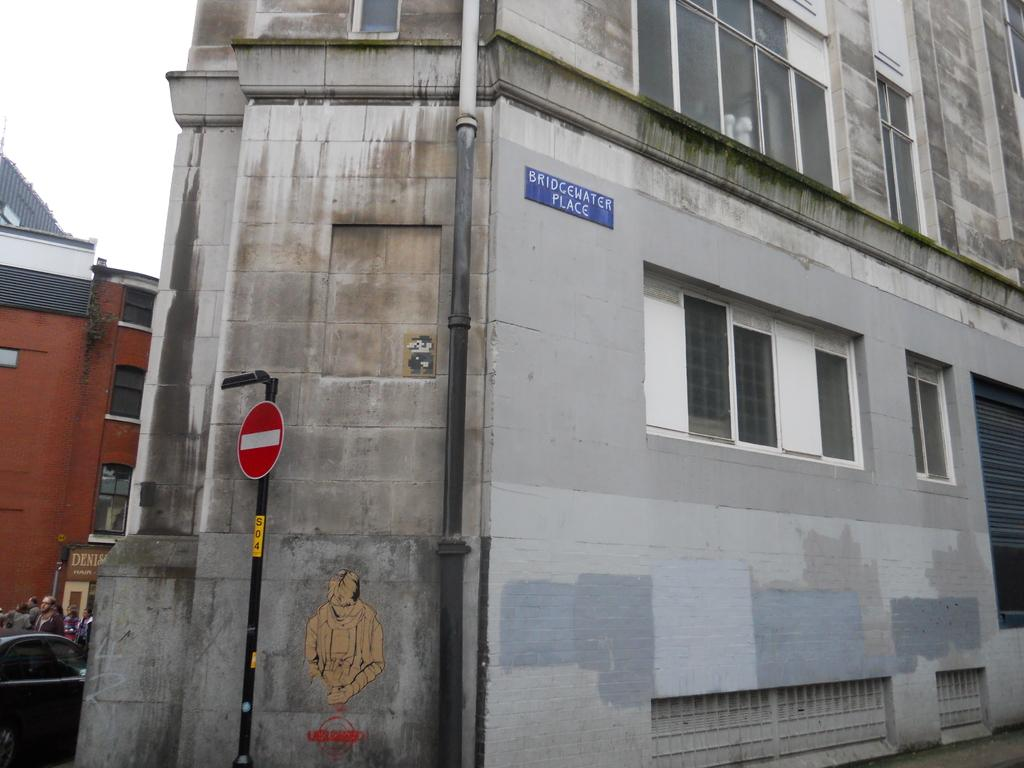What is the main object in the center of the image? There is a pipe in the center of the image. What else is located in the center of the image? There is a building in the center of the image. What can be seen on the left side of the image? There is a building and a person on the left side of the image. What part of the natural environment is visible on the left side of the image? The sky is visible on the left side of the image. What verse can be heard being recited by the flock of friends in the image? There is no verse, flock, or friends present in the image. 